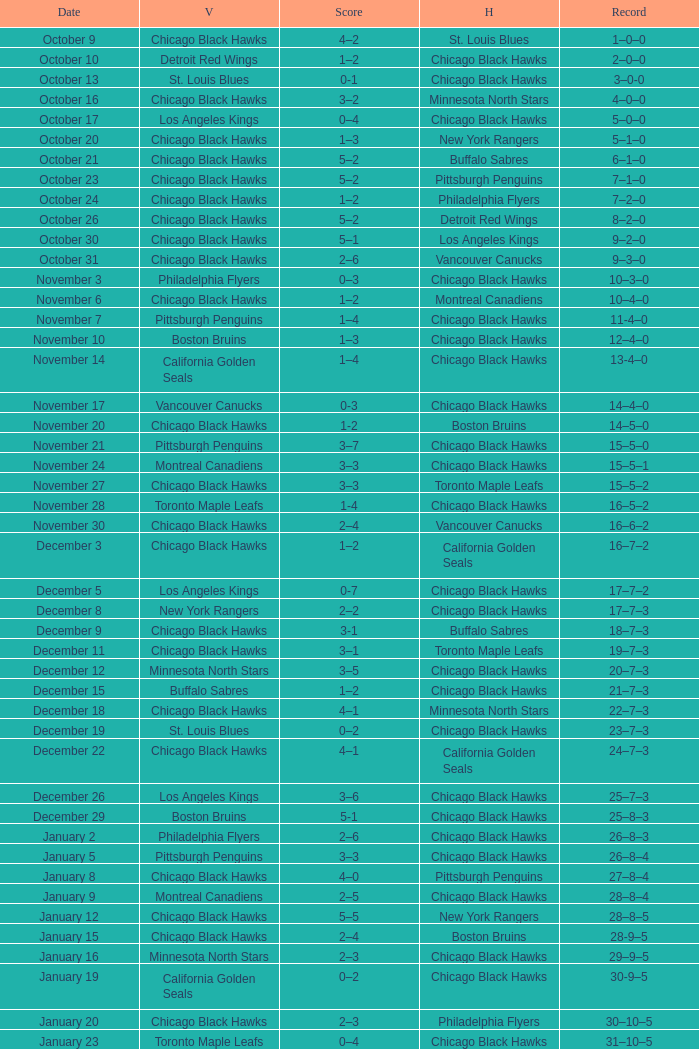What is the Record from February 10? 36–13–5. 